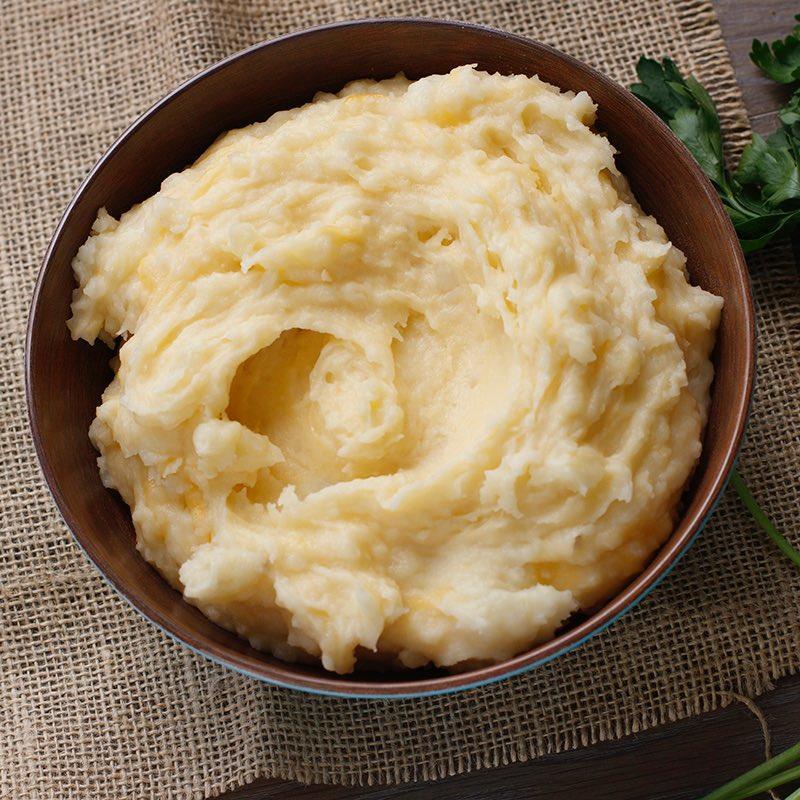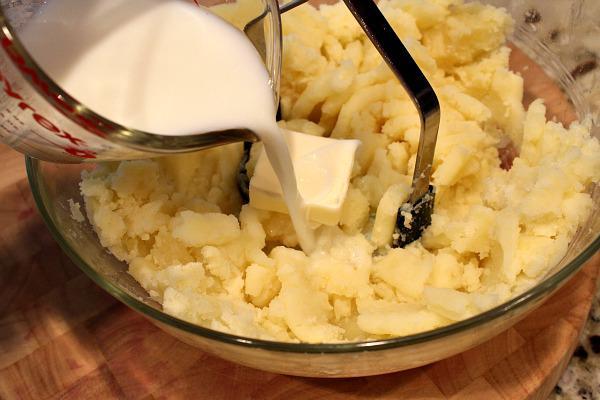The first image is the image on the left, the second image is the image on the right. Assess this claim about the two images: "At least one serving of mashed potato is presented in clear, round glass bowl.". Correct or not? Answer yes or no. Yes. 